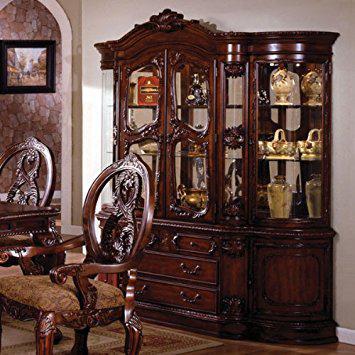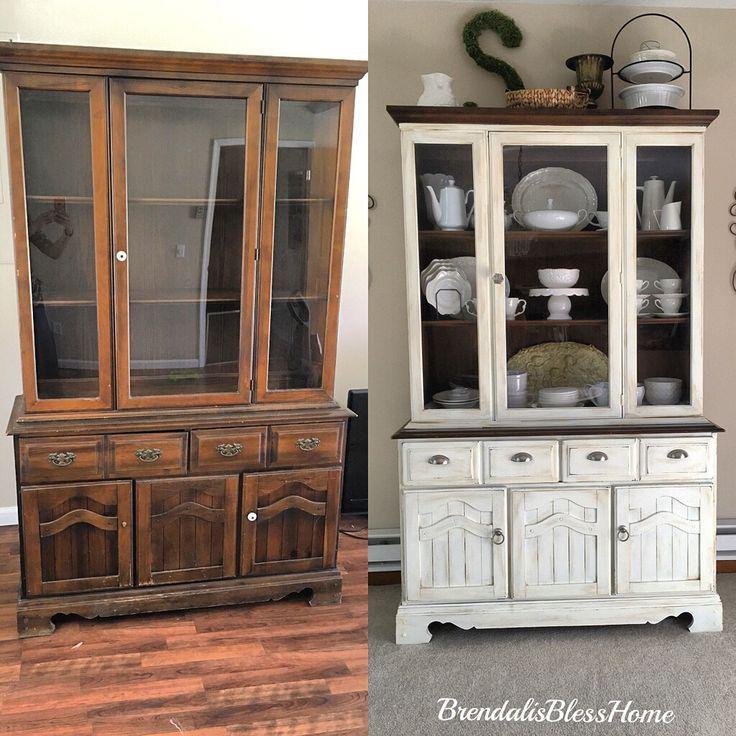The first image is the image on the left, the second image is the image on the right. For the images shown, is this caption "The image on the right  contains a white wooden cabinet." true? Answer yes or no. Yes. The first image is the image on the left, the second image is the image on the right. Evaluate the accuracy of this statement regarding the images: "A brown wooden hutch has a flat top that extends beyond the cabinet, sits on short legs, and has been repurposed in the center bottom section to make a wine rack.". Is it true? Answer yes or no. No. The first image is the image on the left, the second image is the image on the right. Examine the images to the left and right. Is the description "The right image contains a white china cabinet with glass doors." accurate? Answer yes or no. Yes. 